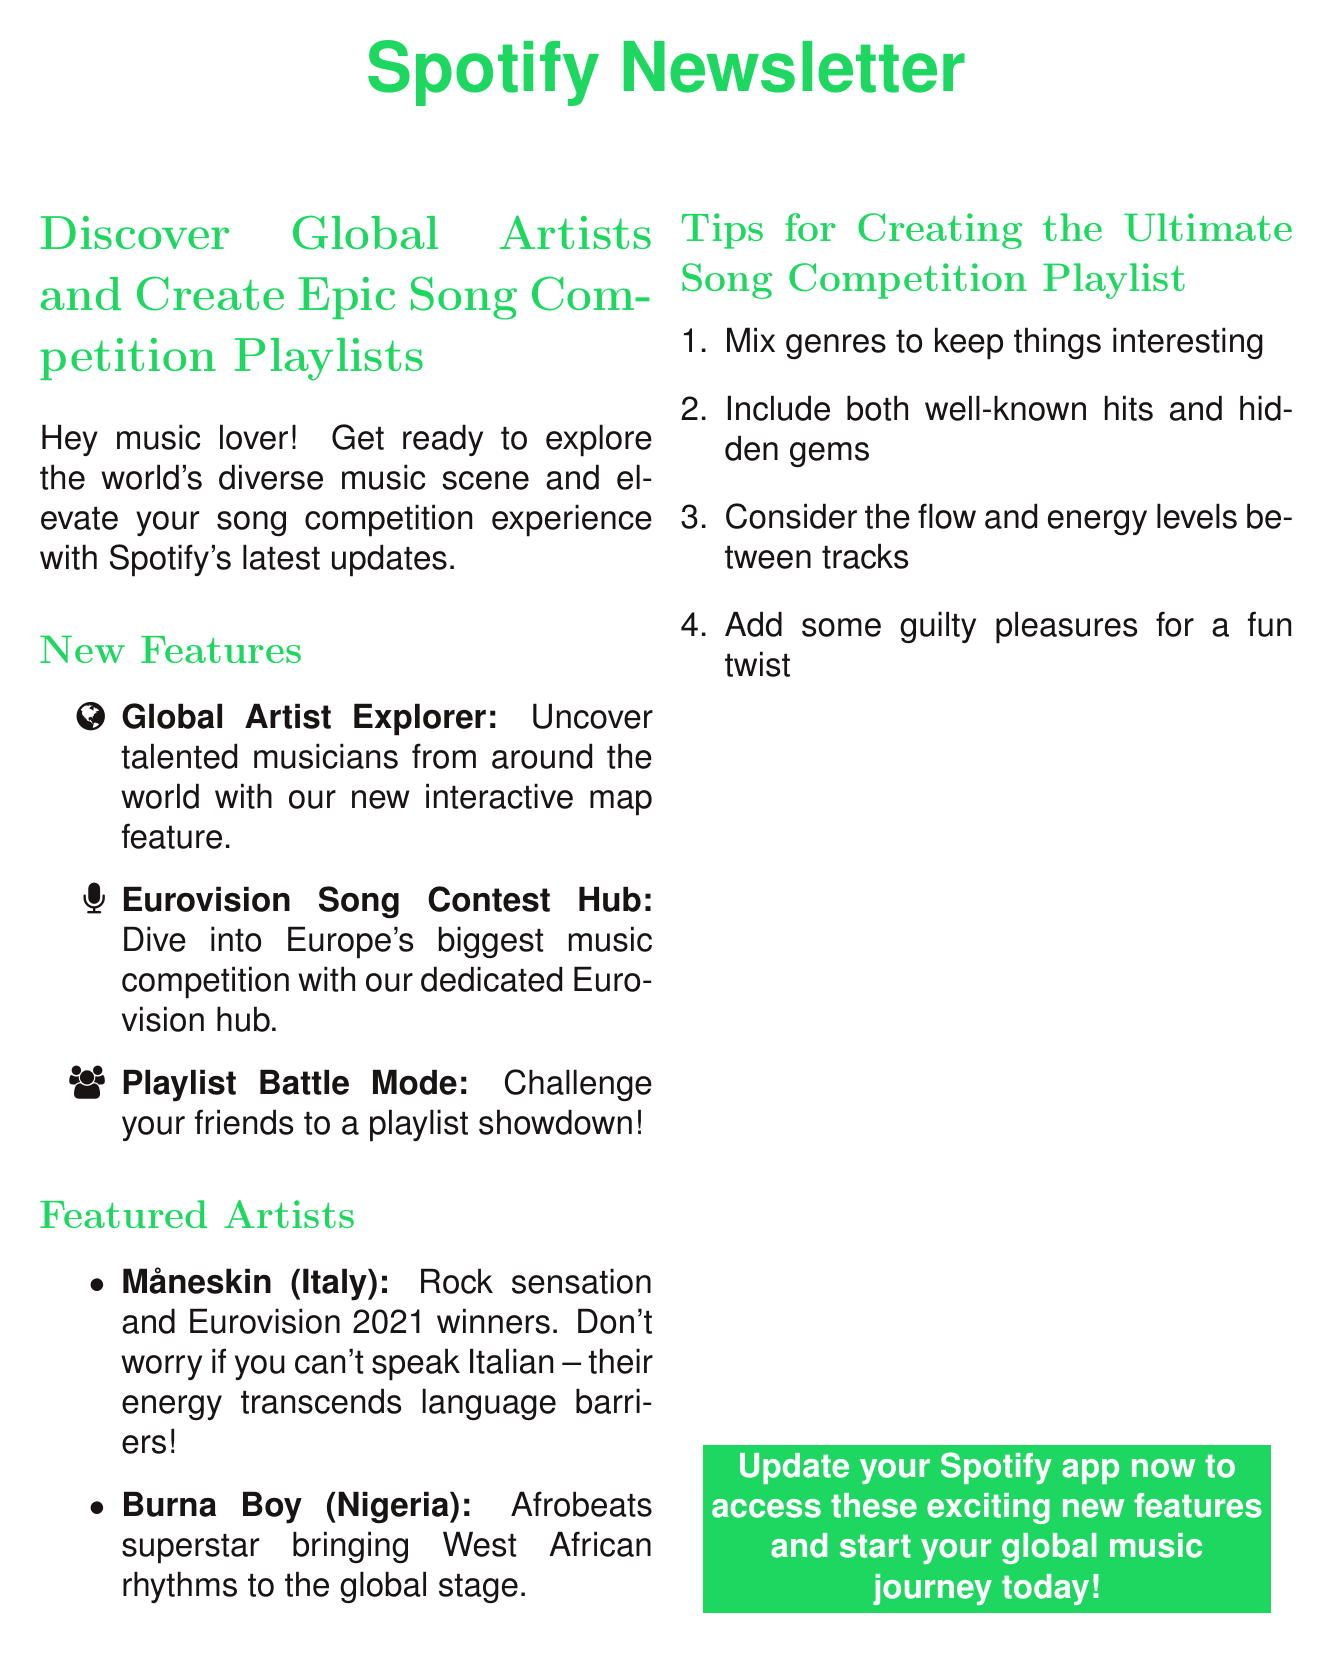What is the first new feature mentioned in the newsletter? The first new feature is "Global Artist Explorer," which aims to uncover talented musicians globally.
Answer: Global Artist Explorer What country is Måneskin from? Måneskin is identified as an artist from Italy in the document.
Answer: Italy How many tips are provided for creating a song competition playlist? There are four tips listed under the tips section for creating a playlist.
Answer: Four What is the purpose of the "Eurovision Song Contest Hub"? The hub allows users to dive into the excitement of Europe's biggest music competition and access all participating songs.
Answer: Access all participating songs Who is described as an Afrobeats superstar? The artist described as an Afrobeats superstar in the newsletter is Burna Boy.
Answer: Burna Boy What kind of feature is "Playlist Battle Mode"? "Playlist Battle Mode" is a challenge feature that allows users to create competing playlists.
Answer: Challenge feature What is the tone of the introduction in the newsletter? The introduction has an enthusiastic tone inviting music lovers to explore new features.
Answer: Enthusiastic tone What should users do to access the new features mentioned in the newsletter? Users are prompted to update their Spotify app to access the new features.
Answer: Update the Spotify app 